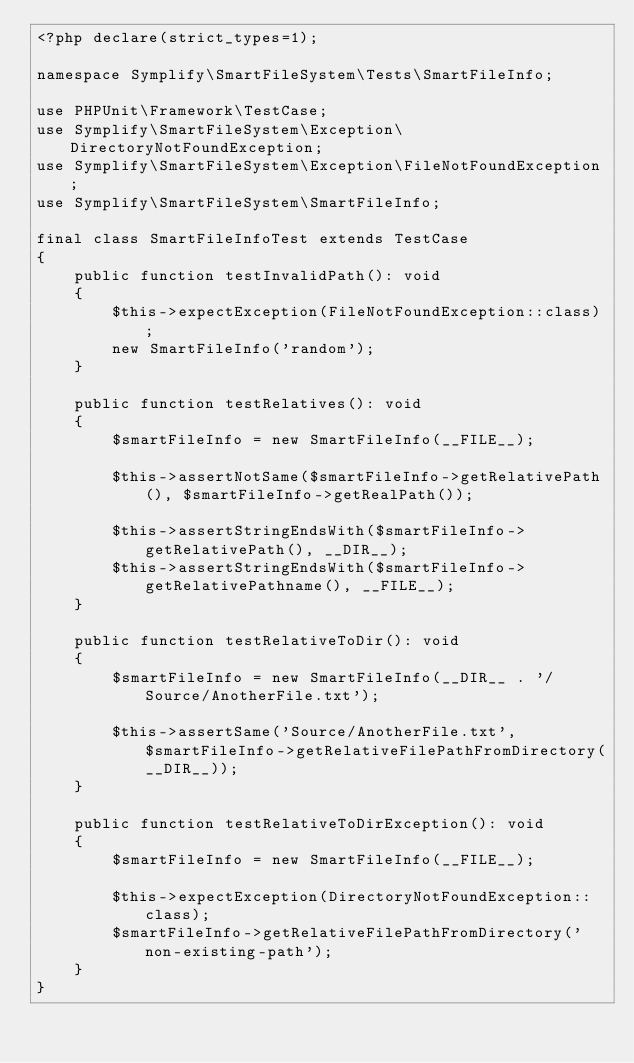Convert code to text. <code><loc_0><loc_0><loc_500><loc_500><_PHP_><?php declare(strict_types=1);

namespace Symplify\SmartFileSystem\Tests\SmartFileInfo;

use PHPUnit\Framework\TestCase;
use Symplify\SmartFileSystem\Exception\DirectoryNotFoundException;
use Symplify\SmartFileSystem\Exception\FileNotFoundException;
use Symplify\SmartFileSystem\SmartFileInfo;

final class SmartFileInfoTest extends TestCase
{
    public function testInvalidPath(): void
    {
        $this->expectException(FileNotFoundException::class);
        new SmartFileInfo('random');
    }

    public function testRelatives(): void
    {
        $smartFileInfo = new SmartFileInfo(__FILE__);

        $this->assertNotSame($smartFileInfo->getRelativePath(), $smartFileInfo->getRealPath());

        $this->assertStringEndsWith($smartFileInfo->getRelativePath(), __DIR__);
        $this->assertStringEndsWith($smartFileInfo->getRelativePathname(), __FILE__);
    }

    public function testRelativeToDir(): void
    {
        $smartFileInfo = new SmartFileInfo(__DIR__ . '/Source/AnotherFile.txt');

        $this->assertSame('Source/AnotherFile.txt', $smartFileInfo->getRelativeFilePathFromDirectory(__DIR__));
    }

    public function testRelativeToDirException(): void
    {
        $smartFileInfo = new SmartFileInfo(__FILE__);

        $this->expectException(DirectoryNotFoundException::class);
        $smartFileInfo->getRelativeFilePathFromDirectory('non-existing-path');
    }
}
</code> 